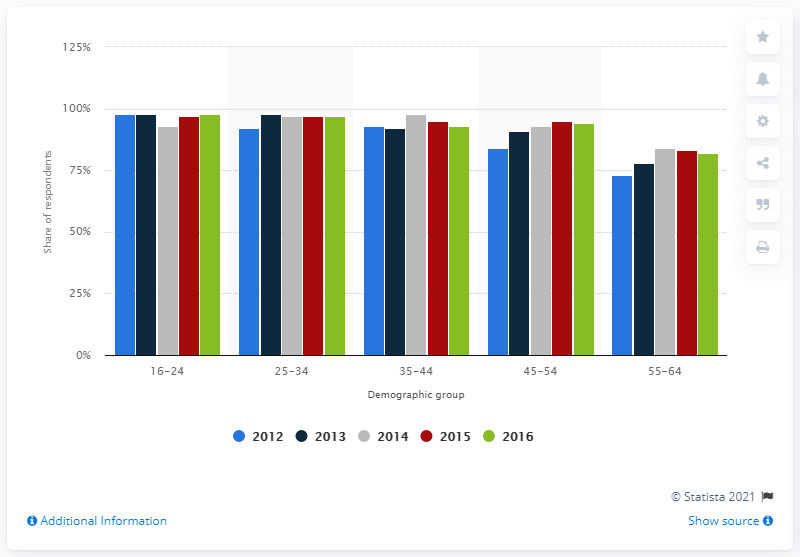In what year was the UK's internet usage survey conducted? The UK's internet usage survey depicted in the chart appears to have been carried out over multiple years, including 2012, 2013, 2014, and 2016. Each colored bar represents a different year's data for various demographic groups. 